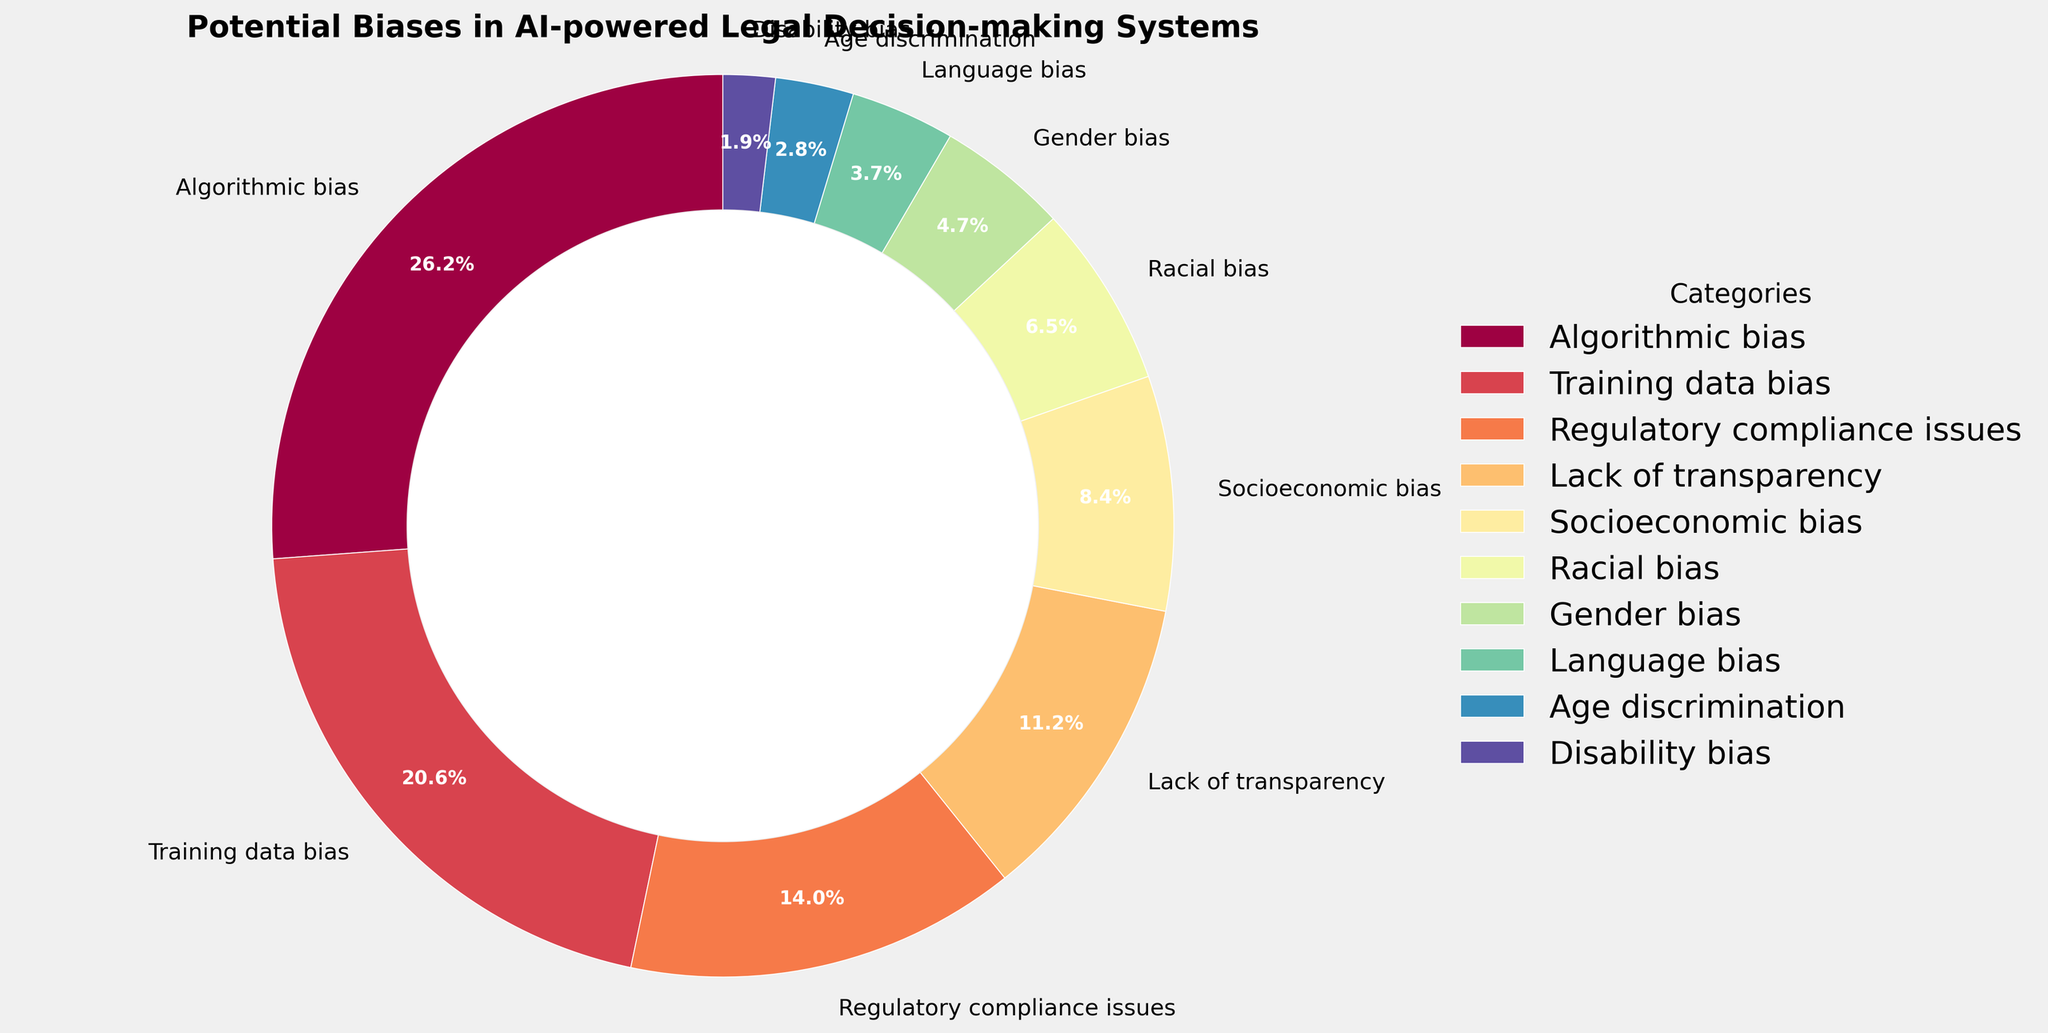What percentage of potential biases in AI-powered legal decision-making systems is attributed to "Algorithmic bias"? First, locate the "Algorithmic bias" slice in the pie chart. Next, refer to the displayed percentage for this category.
Answer: 28% How do "Training data bias" and "Regulatory compliance issues" together compare to "Algorithmic bias"? First, find the percentages for "Training data bias" (22%) and "Regulatory compliance issues" (15%). Then, add these values together (22% + 15% = 37%). Finally, compare the sum to the percentage for "Algorithmic bias" (28%).
Answer: 37% > 28% What is the combined percentage of "Racial bias", "Gender bias", and "Language bias"? Identify the percentages for "Racial bias" (7%), "Gender bias" (5%), and "Language bias" (4%). Sum these percentages (7% + 5% + 4% = 16%).
Answer: 16% Which category has the smallest percentage, and what is it? Find the slice with the smallest percentage in the pie chart, which is "Disability bias". Refer to the associated percentage.
Answer: Disability bias, 2% Is the percentage of "Age discrimination" higher or lower than that of "Socioeconomic bias"? Find the percentages for "Age discrimination" (3%) and "Socioeconomic bias" (9%). Compare both values.
Answer: lower What's the visual color of the category "Lack of transparency"? Locate the slice labeled "Lack of transparency" and identify its color from the pie chart.
Answer: answer depends on chart colors but assume it's dark blue or similar How much greater is the percentage of "Algorithmic bias" compared to "Gender bias"? Identify the percentages for "Algorithmic bias" (28%) and "Gender bias" (5%). Subtract the percentage of "Gender bias" from that of "Algorithmic bias" (28% - 5% = 23%).
Answer: 23% What are the four smallest categories by percentage in descending order? Identify the four smallest percentages: "Disability bias" (2%), "Age discrimination" (3%), "Language bias" (4%), and "Gender bias" (5%). List these in descending order.
Answer: Gender bias, Language bias, Age discrimination, Disability bias What portion of the pie chart represents "Socioeconomic bias"? Locate the "Socioeconomic bias" slice and note the visual portion. Verify with the percentage listed, which is 9%.
Answer: 9% Compare the combined percentage of "Disability bias" and "Age discrimination" with "Lack of transparency". Find the percentages for "Disability bias" (2%) and "Age discrimination" (3%). Sum these percentages (2% + 3% = 5%). Compare this sum to "Lack of transparency" (12%).
Answer: 5% < 12% 